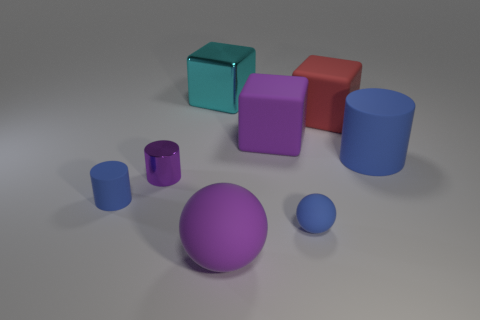What size is the purple sphere that is the same material as the tiny blue ball?
Provide a succinct answer. Large. Are there any tiny cylinders behind the large cylinder?
Give a very brief answer. No. What size is the other blue matte thing that is the same shape as the big blue object?
Provide a short and direct response. Small. Is the color of the tiny ball the same as the rubber cylinder that is to the right of the purple matte sphere?
Keep it short and to the point. Yes. Is the big rubber cylinder the same color as the small rubber ball?
Offer a very short reply. Yes. Are there fewer tiny green matte cylinders than metal cylinders?
Provide a succinct answer. Yes. How many other things are there of the same color as the big ball?
Your answer should be compact. 2. How many small rubber spheres are there?
Keep it short and to the point. 1. Are there fewer purple objects that are to the right of the big cylinder than green things?
Offer a terse response. No. Are the tiny blue object that is left of the large cyan shiny thing and the big purple ball made of the same material?
Offer a very short reply. Yes. 